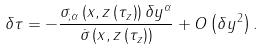Convert formula to latex. <formula><loc_0><loc_0><loc_500><loc_500>\delta \tau = - \frac { \sigma _ { ; \alpha } \left ( x , z \left ( \tau _ { z } \right ) \right ) \delta y ^ { \alpha } } { \dot { \sigma } \left ( x , z \left ( \tau _ { z } \right ) \right ) } + O \left ( \delta y ^ { 2 } \right ) .</formula> 